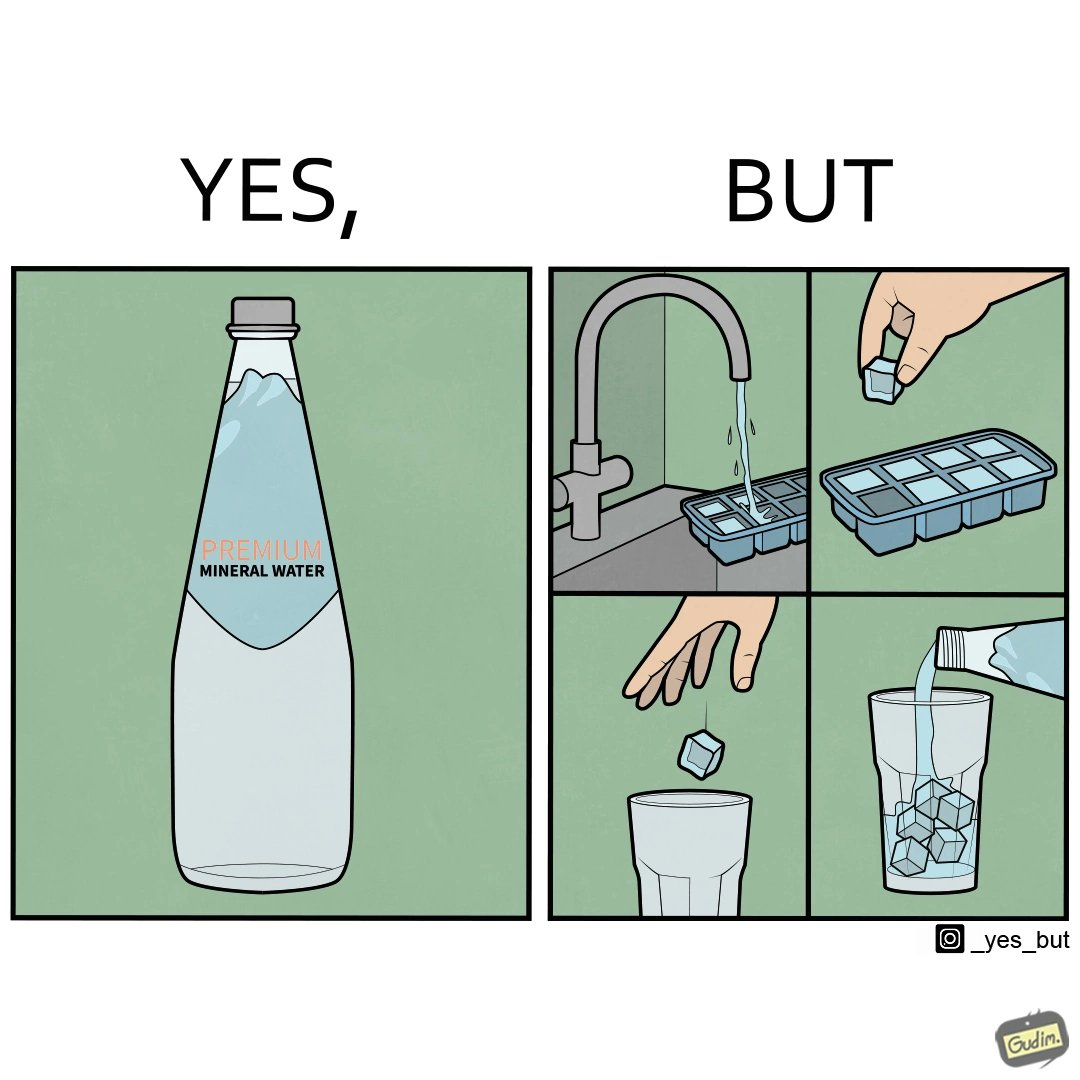What does this image depict? This image is ironical, as a bottle of mineral water is being used along with ice cubes from tap water, while the sama tap water could have been instead used. 